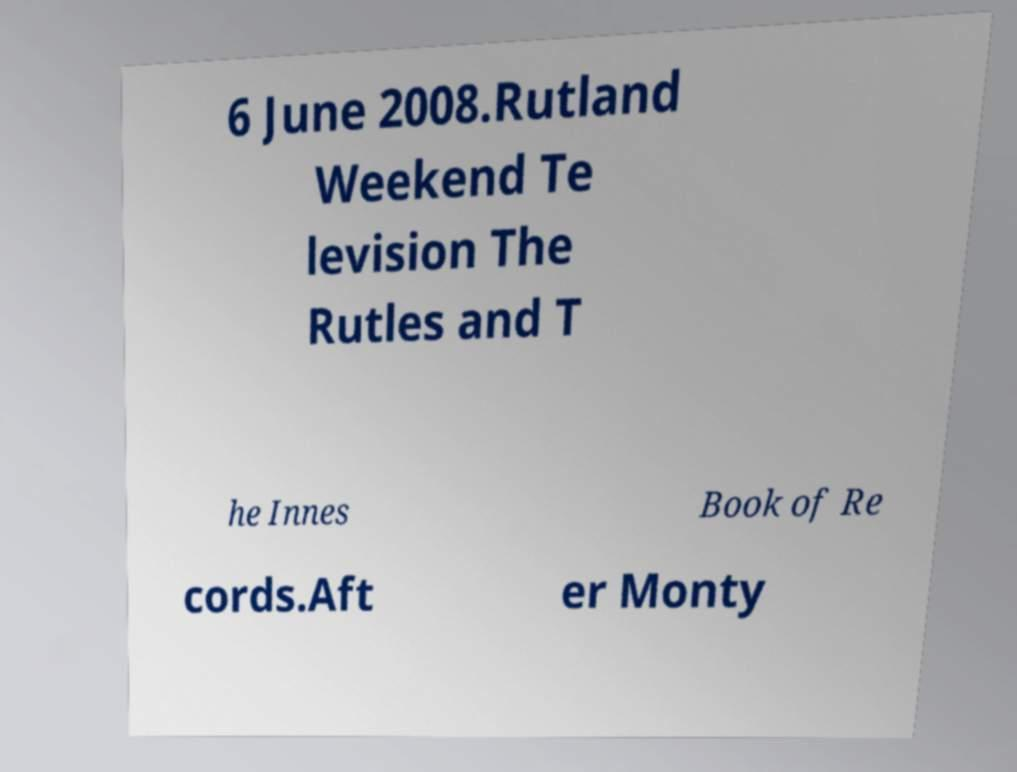For documentation purposes, I need the text within this image transcribed. Could you provide that? 6 June 2008.Rutland Weekend Te levision The Rutles and T he Innes Book of Re cords.Aft er Monty 